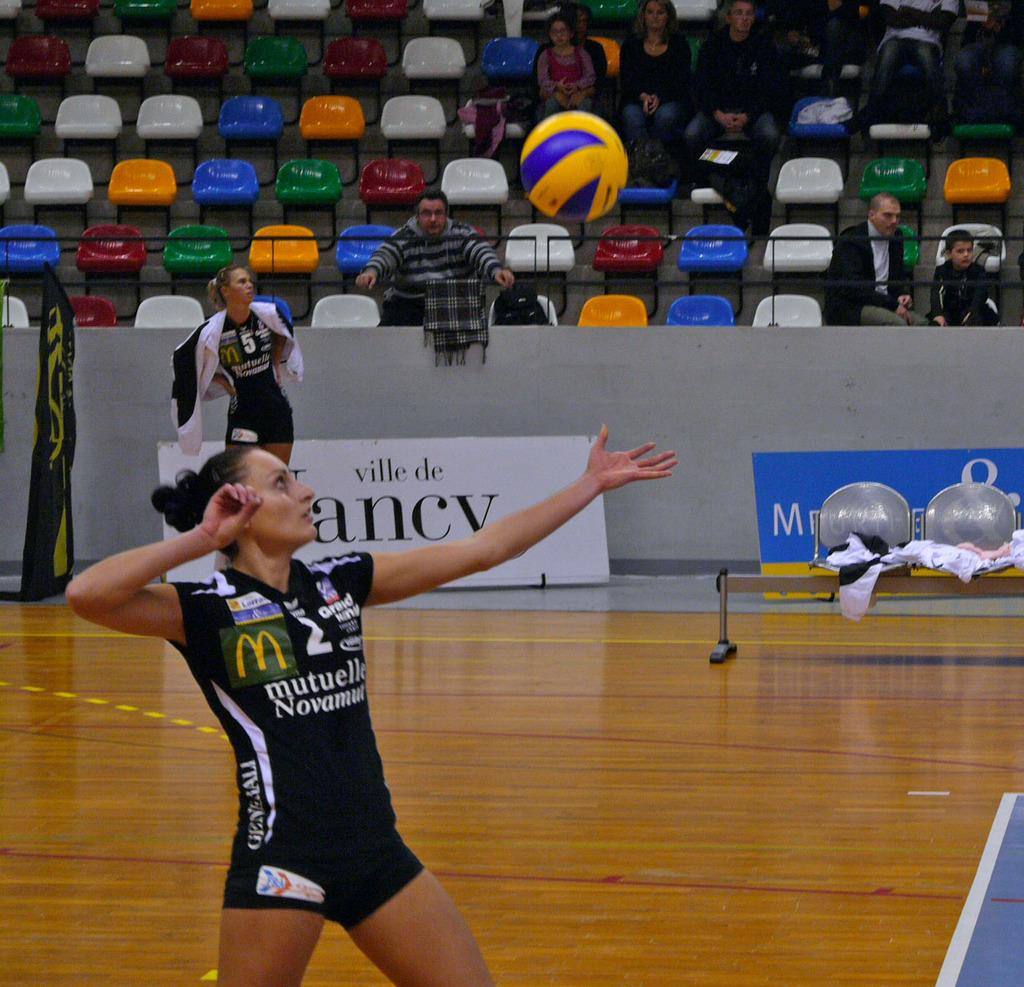<image>
Render a clear and concise summary of the photo. a female basketball player for the mutuelle novamut team 